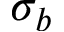Convert formula to latex. <formula><loc_0><loc_0><loc_500><loc_500>\sigma _ { b }</formula> 